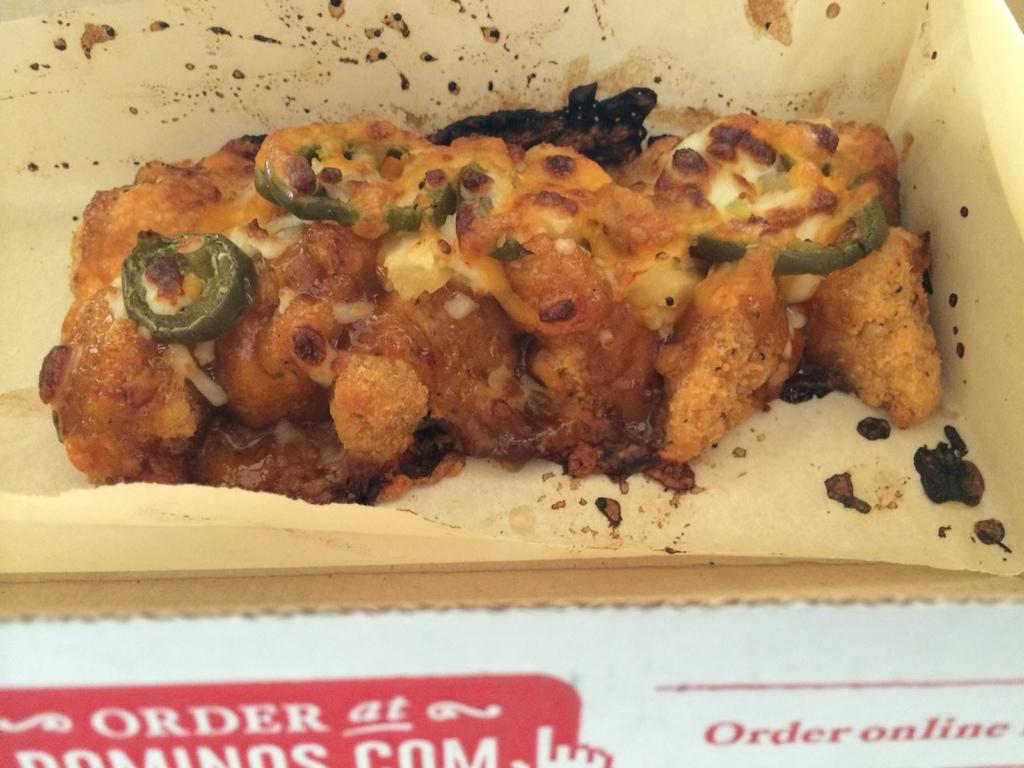What is inside the box that is visible in the image? There is a food item inside the box in the image. How many arithmetic problems are solved on the art piece inside the box? There is no art piece or arithmetic problems present inside the box; it contains a food item. 